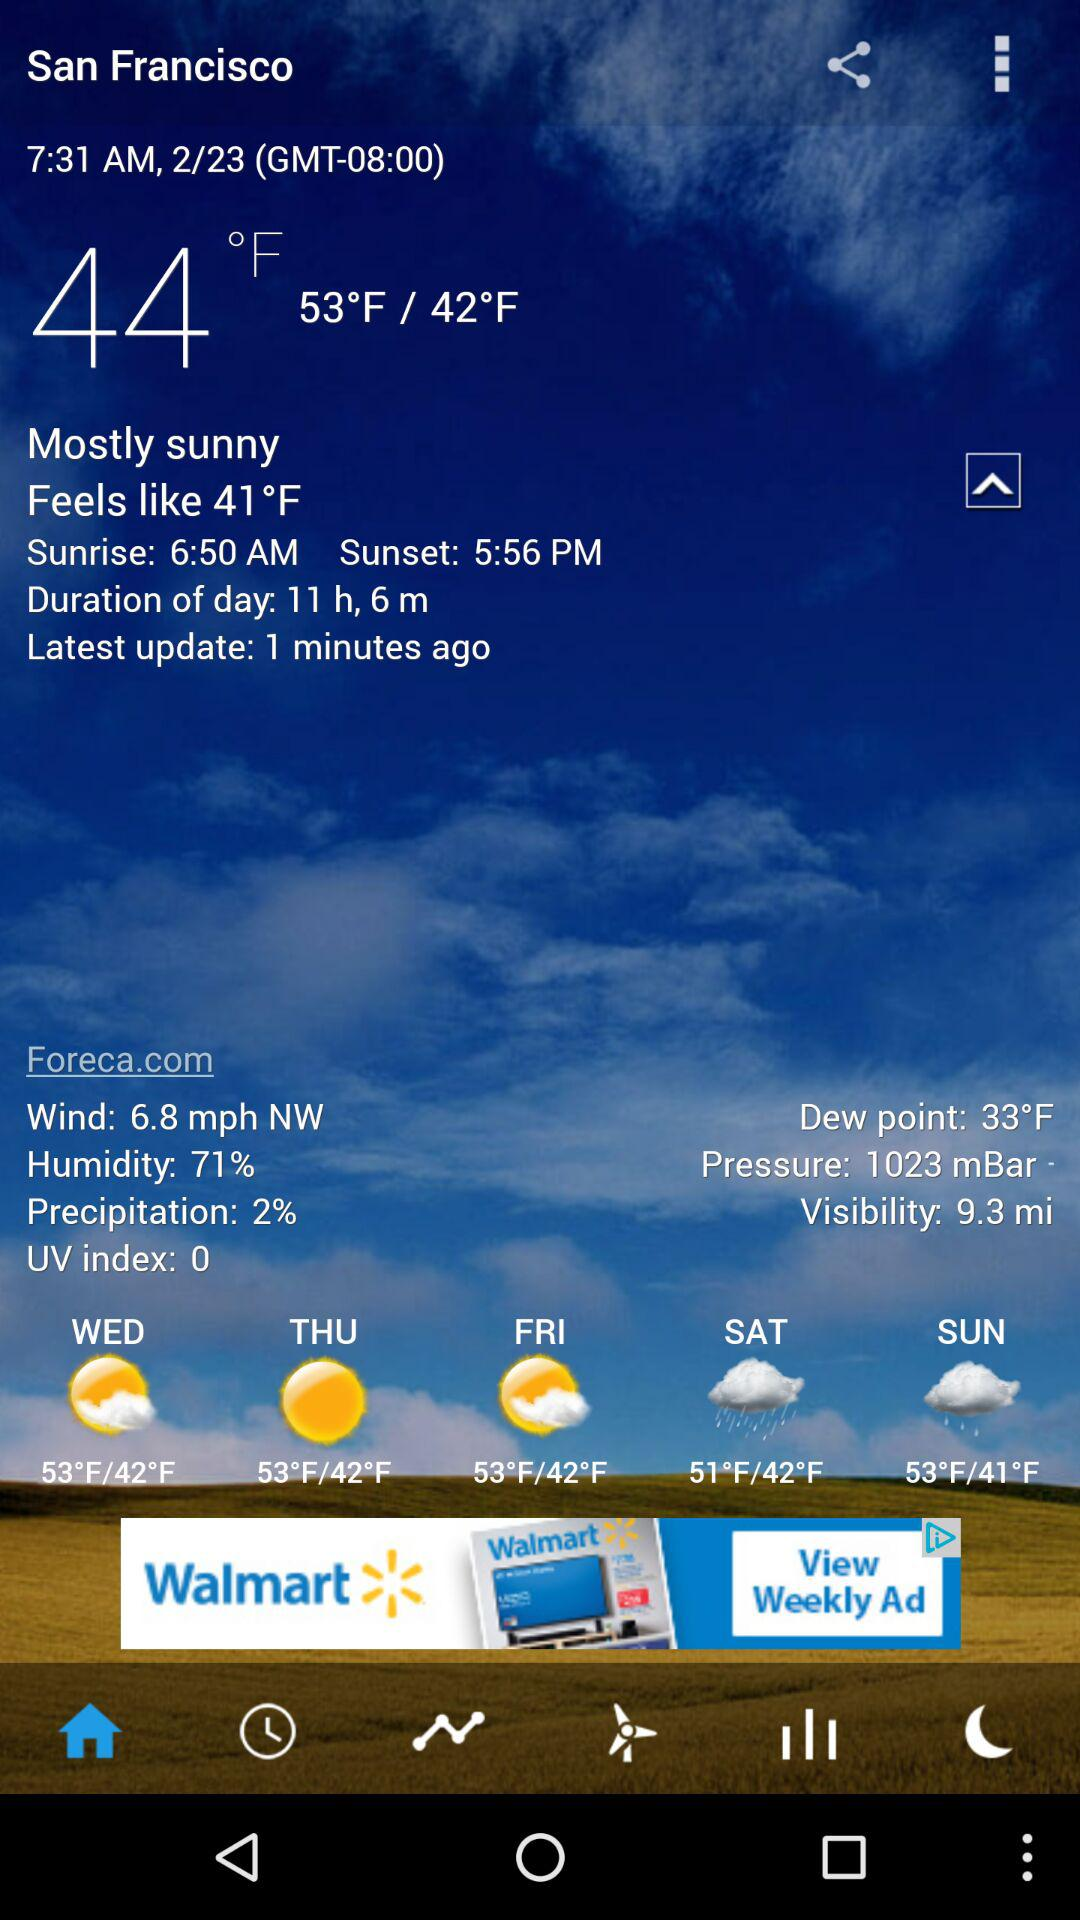At what time will the sun set? The sun will set at 5:56 PM. 